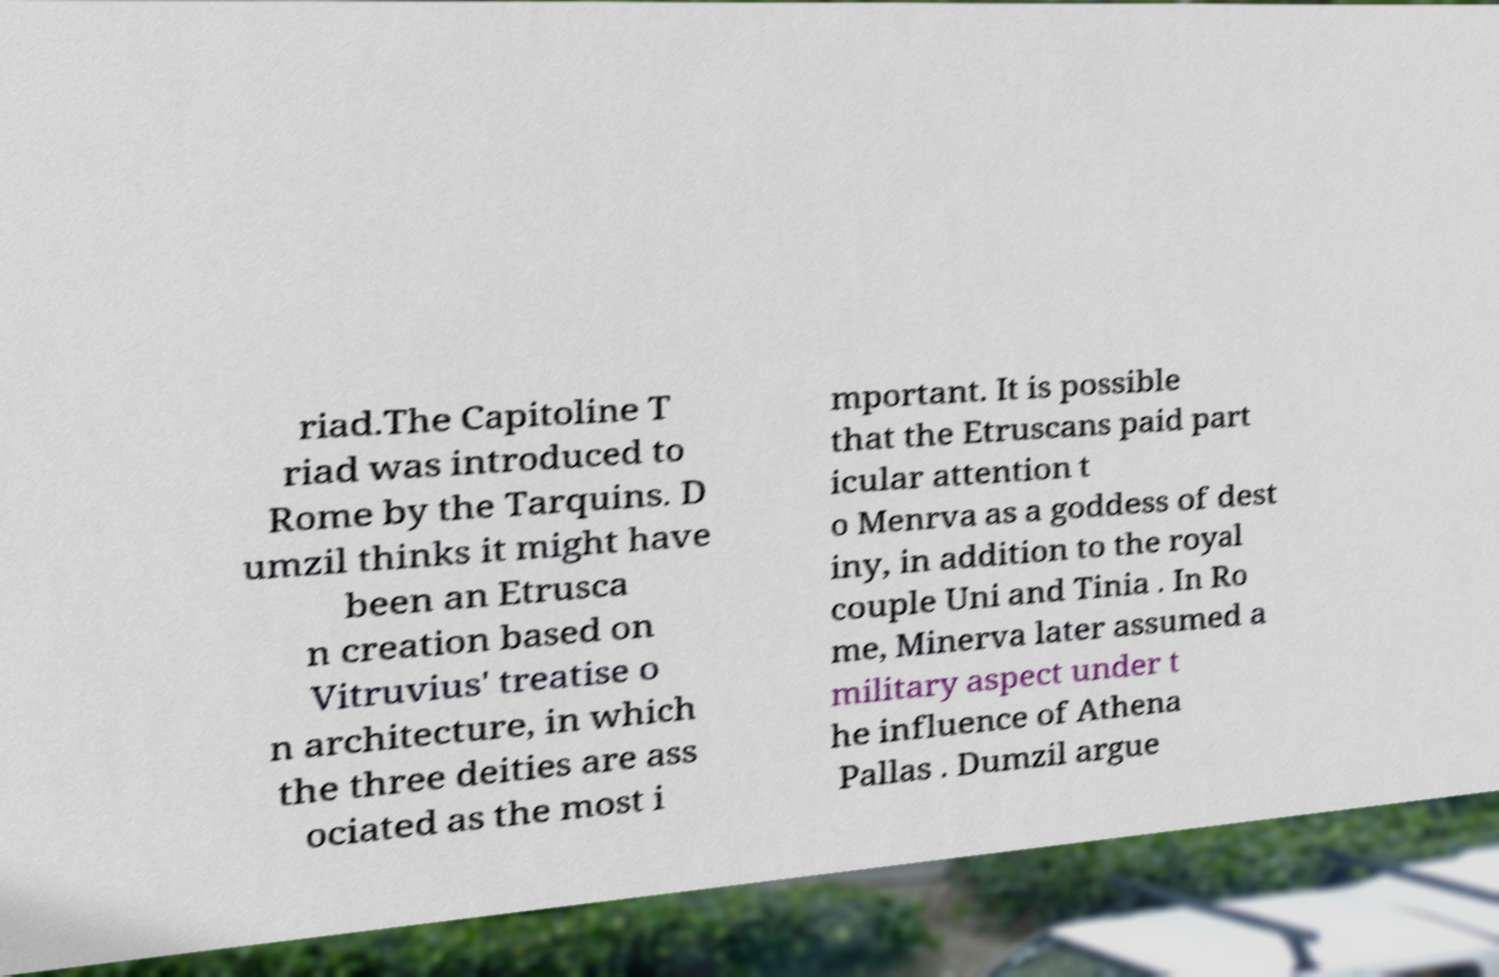What messages or text are displayed in this image? I need them in a readable, typed format. riad.The Capitoline T riad was introduced to Rome by the Tarquins. D umzil thinks it might have been an Etrusca n creation based on Vitruvius' treatise o n architecture, in which the three deities are ass ociated as the most i mportant. It is possible that the Etruscans paid part icular attention t o Menrva as a goddess of dest iny, in addition to the royal couple Uni and Tinia . In Ro me, Minerva later assumed a military aspect under t he influence of Athena Pallas . Dumzil argue 